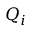<formula> <loc_0><loc_0><loc_500><loc_500>Q _ { i }</formula> 